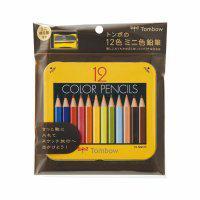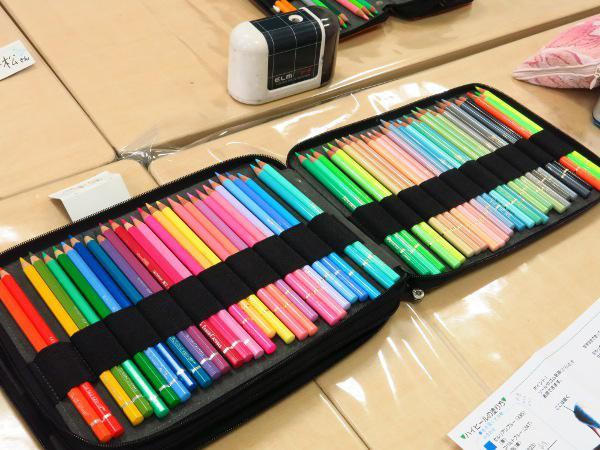The first image is the image on the left, the second image is the image on the right. Assess this claim about the two images: "Each image includes colored pencils, and at least one image shows an open pencil case that has a long black strap running its length to secure the pencils.". Correct or not? Answer yes or no. Yes. The first image is the image on the left, the second image is the image on the right. For the images shown, is this caption "Both images feature pencils strapped inside a case." true? Answer yes or no. No. 